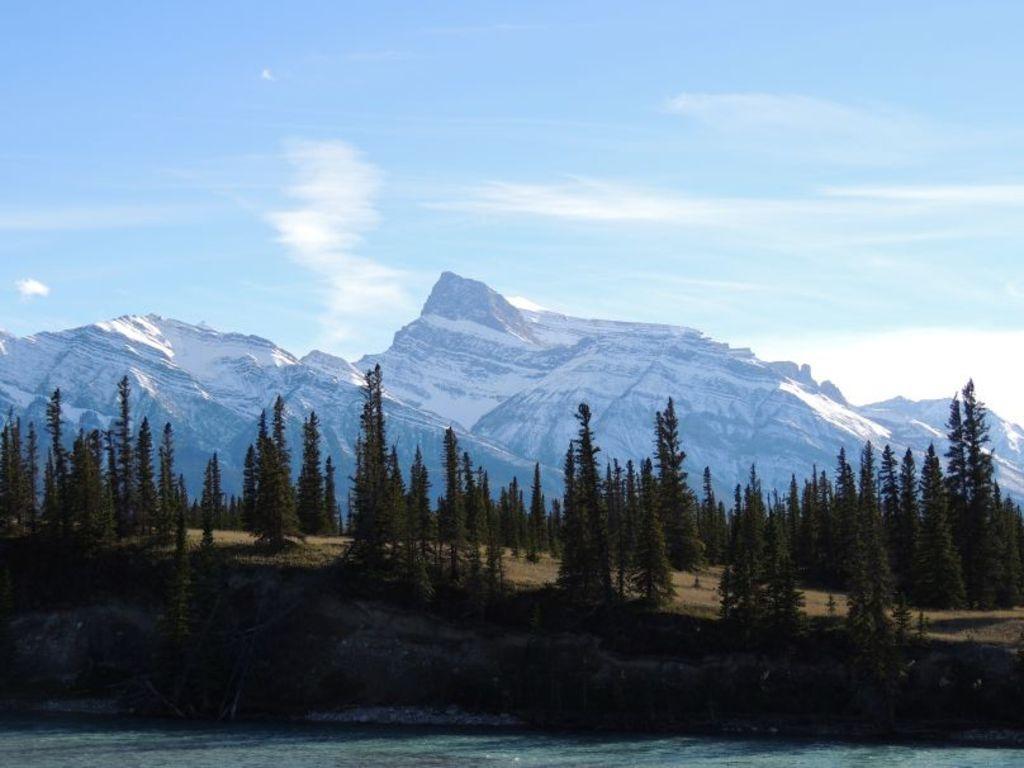Could you give a brief overview of what you see in this image? At the bottom of the picture, we see water and this water might be in the lake. In the middle of the picture, we see the trees. There are mountains in the background. At the top, we see the sky and the clouds. 